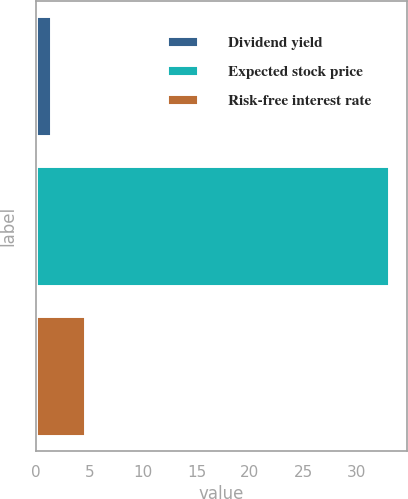<chart> <loc_0><loc_0><loc_500><loc_500><bar_chart><fcel>Dividend yield<fcel>Expected stock price<fcel>Risk-free interest rate<nl><fcel>1.4<fcel>33<fcel>4.56<nl></chart> 